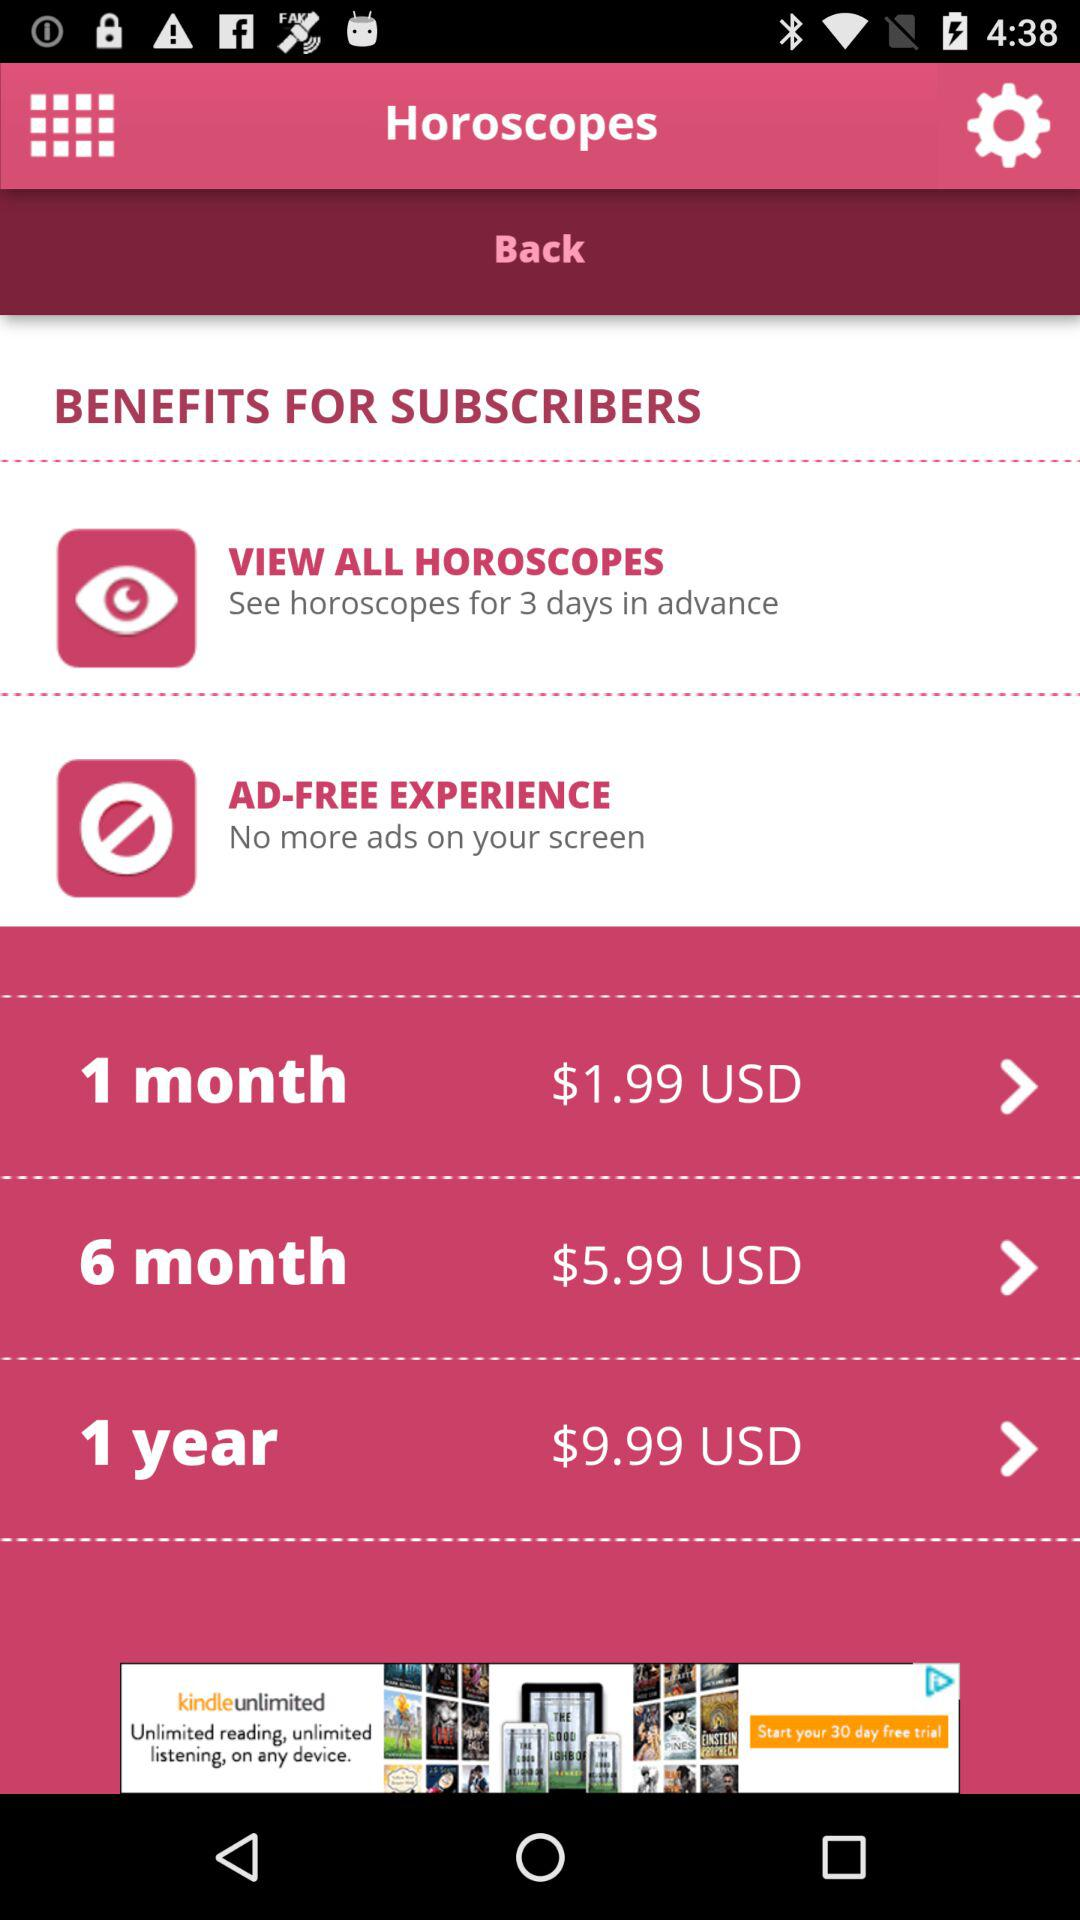How much money do we spend on the one-year plan in USD? You do spend $9.99 USD. 